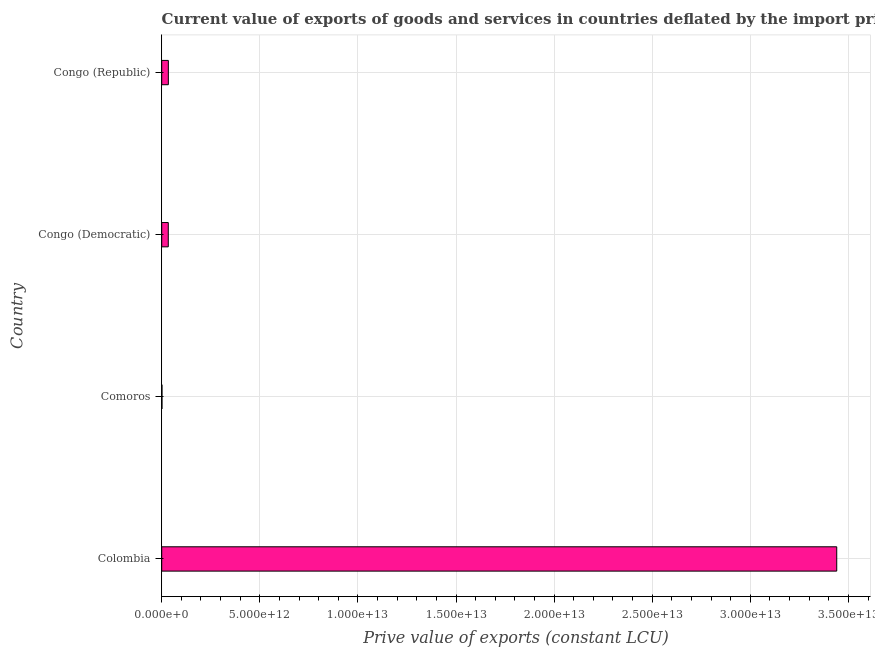Does the graph contain grids?
Provide a short and direct response. Yes. What is the title of the graph?
Give a very brief answer. Current value of exports of goods and services in countries deflated by the import price index. What is the label or title of the X-axis?
Offer a very short reply. Prive value of exports (constant LCU). What is the label or title of the Y-axis?
Make the answer very short. Country. What is the price value of exports in Colombia?
Offer a very short reply. 3.44e+13. Across all countries, what is the maximum price value of exports?
Your response must be concise. 3.44e+13. Across all countries, what is the minimum price value of exports?
Offer a terse response. 1.48e+1. In which country was the price value of exports maximum?
Provide a short and direct response. Colombia. In which country was the price value of exports minimum?
Provide a short and direct response. Comoros. What is the sum of the price value of exports?
Provide a short and direct response. 3.51e+13. What is the difference between the price value of exports in Colombia and Congo (Democratic)?
Keep it short and to the point. 3.41e+13. What is the average price value of exports per country?
Your response must be concise. 8.77e+12. What is the median price value of exports?
Ensure brevity in your answer.  3.36e+11. In how many countries, is the price value of exports greater than 22000000000000 LCU?
Give a very brief answer. 1. What is the ratio of the price value of exports in Colombia to that in Congo (Republic)?
Your answer should be compact. 101.77. What is the difference between the highest and the second highest price value of exports?
Your response must be concise. 3.41e+13. What is the difference between the highest and the lowest price value of exports?
Give a very brief answer. 3.44e+13. How many bars are there?
Keep it short and to the point. 4. How many countries are there in the graph?
Provide a succinct answer. 4. What is the difference between two consecutive major ticks on the X-axis?
Your answer should be very brief. 5.00e+12. Are the values on the major ticks of X-axis written in scientific E-notation?
Make the answer very short. Yes. What is the Prive value of exports (constant LCU) of Colombia?
Ensure brevity in your answer.  3.44e+13. What is the Prive value of exports (constant LCU) of Comoros?
Provide a succinct answer. 1.48e+1. What is the Prive value of exports (constant LCU) in Congo (Democratic)?
Give a very brief answer. 3.35e+11. What is the Prive value of exports (constant LCU) in Congo (Republic)?
Your response must be concise. 3.38e+11. What is the difference between the Prive value of exports (constant LCU) in Colombia and Comoros?
Make the answer very short. 3.44e+13. What is the difference between the Prive value of exports (constant LCU) in Colombia and Congo (Democratic)?
Offer a very short reply. 3.41e+13. What is the difference between the Prive value of exports (constant LCU) in Colombia and Congo (Republic)?
Make the answer very short. 3.41e+13. What is the difference between the Prive value of exports (constant LCU) in Comoros and Congo (Democratic)?
Ensure brevity in your answer.  -3.20e+11. What is the difference between the Prive value of exports (constant LCU) in Comoros and Congo (Republic)?
Offer a terse response. -3.23e+11. What is the difference between the Prive value of exports (constant LCU) in Congo (Democratic) and Congo (Republic)?
Your answer should be compact. -3.28e+09. What is the ratio of the Prive value of exports (constant LCU) in Colombia to that in Comoros?
Provide a succinct answer. 2327.37. What is the ratio of the Prive value of exports (constant LCU) in Colombia to that in Congo (Democratic)?
Your answer should be very brief. 102.77. What is the ratio of the Prive value of exports (constant LCU) in Colombia to that in Congo (Republic)?
Offer a terse response. 101.77. What is the ratio of the Prive value of exports (constant LCU) in Comoros to that in Congo (Democratic)?
Give a very brief answer. 0.04. What is the ratio of the Prive value of exports (constant LCU) in Comoros to that in Congo (Republic)?
Provide a succinct answer. 0.04. What is the ratio of the Prive value of exports (constant LCU) in Congo (Democratic) to that in Congo (Republic)?
Keep it short and to the point. 0.99. 